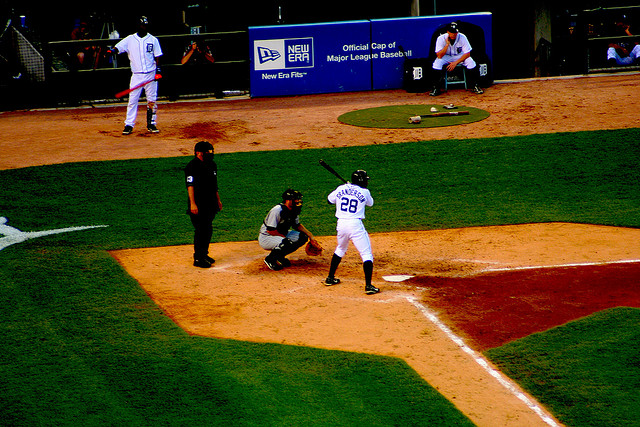<image>What is the website on the board? I am not sure what the website on the board is, it could be 'new era', 'mlbcom' or there might be no website at all. What is the website on the board? I don't know the website on the board. It can be 'new era' or 'mlbcom'. 